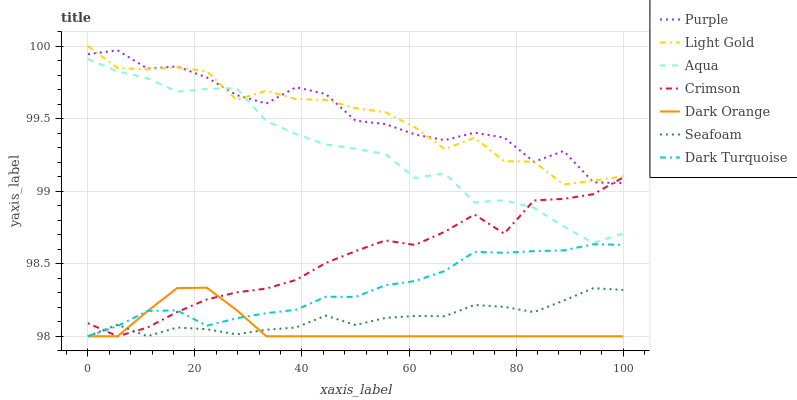Does Dark Orange have the minimum area under the curve?
Answer yes or no. Yes. Does Purple have the maximum area under the curve?
Answer yes or no. Yes. Does Dark Turquoise have the minimum area under the curve?
Answer yes or no. No. Does Dark Turquoise have the maximum area under the curve?
Answer yes or no. No. Is Dark Orange the smoothest?
Answer yes or no. Yes. Is Purple the roughest?
Answer yes or no. Yes. Is Dark Turquoise the smoothest?
Answer yes or no. No. Is Dark Turquoise the roughest?
Answer yes or no. No. Does Dark Orange have the lowest value?
Answer yes or no. Yes. Does Purple have the lowest value?
Answer yes or no. No. Does Light Gold have the highest value?
Answer yes or no. Yes. Does Purple have the highest value?
Answer yes or no. No. Is Crimson less than Light Gold?
Answer yes or no. Yes. Is Aqua greater than Seafoam?
Answer yes or no. Yes. Does Light Gold intersect Purple?
Answer yes or no. Yes. Is Light Gold less than Purple?
Answer yes or no. No. Is Light Gold greater than Purple?
Answer yes or no. No. Does Crimson intersect Light Gold?
Answer yes or no. No. 